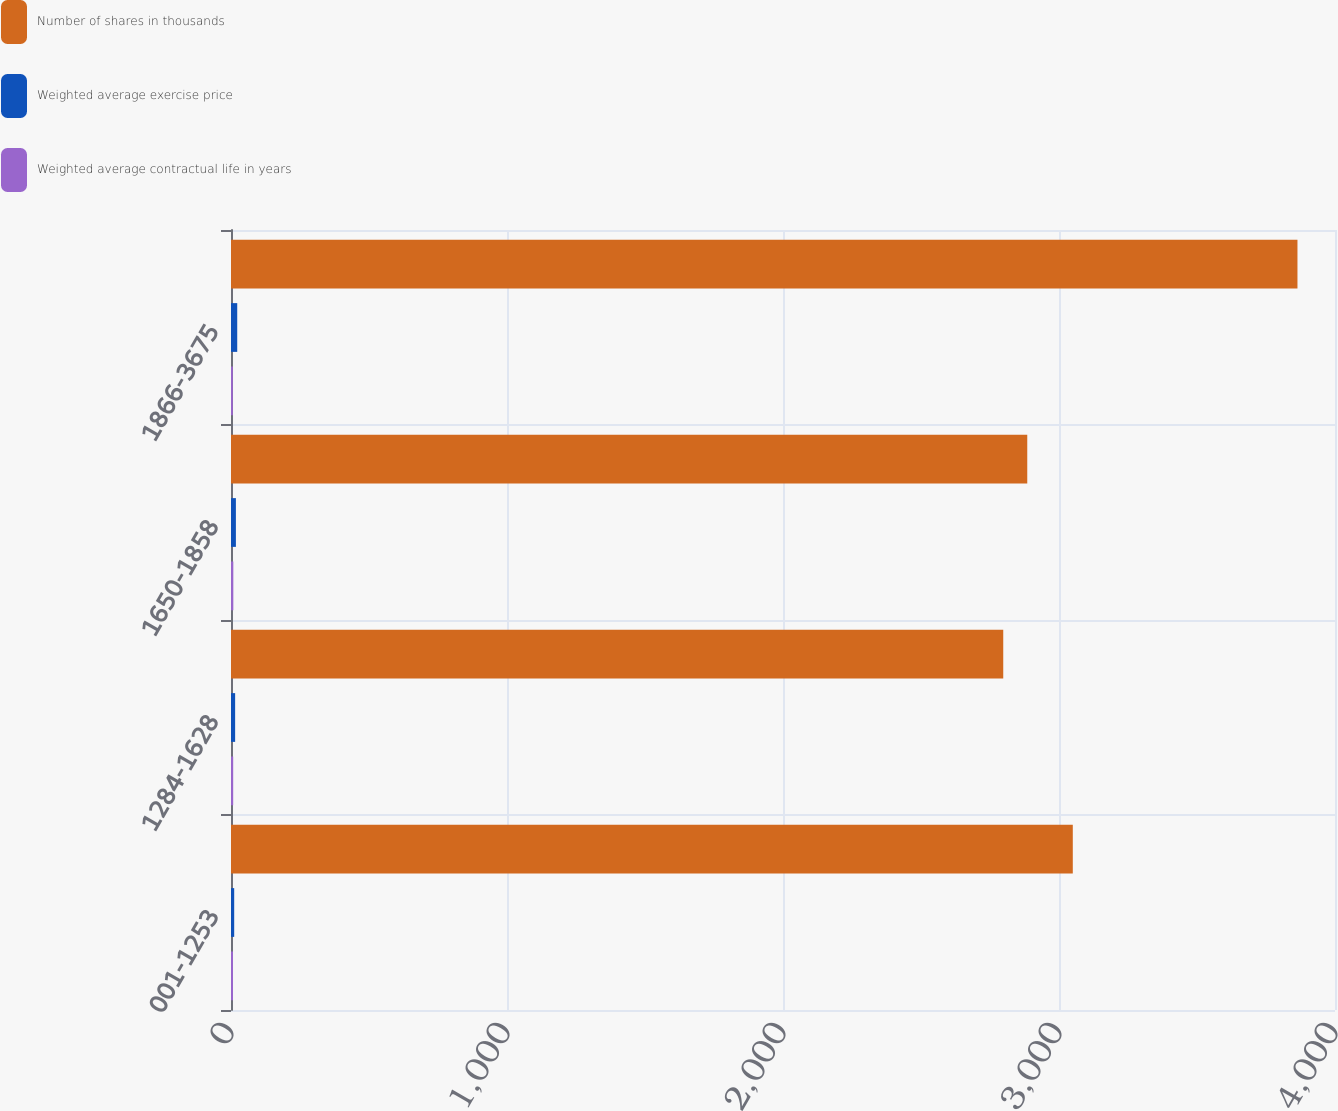Convert chart to OTSL. <chart><loc_0><loc_0><loc_500><loc_500><stacked_bar_chart><ecel><fcel>001-1253<fcel>1284-1628<fcel>1650-1858<fcel>1866-3675<nl><fcel>Number of shares in thousands<fcel>3050<fcel>2798<fcel>2885<fcel>3864<nl><fcel>Weighted average exercise price<fcel>11.56<fcel>14.98<fcel>17.75<fcel>22.57<nl><fcel>Weighted average contractual life in years<fcel>7.3<fcel>7.9<fcel>8.4<fcel>6.7<nl></chart> 